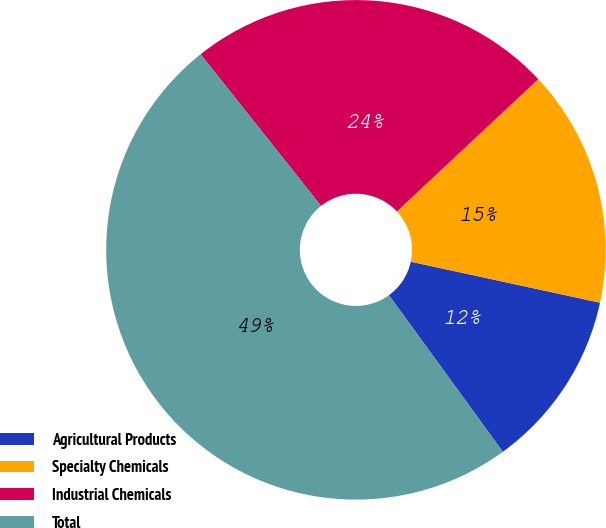Convert chart to OTSL. <chart><loc_0><loc_0><loc_500><loc_500><pie_chart><fcel>Agricultural Products<fcel>Specialty Chemicals<fcel>Industrial Chemicals<fcel>Total<nl><fcel>11.6%<fcel>15.37%<fcel>23.71%<fcel>49.32%<nl></chart> 